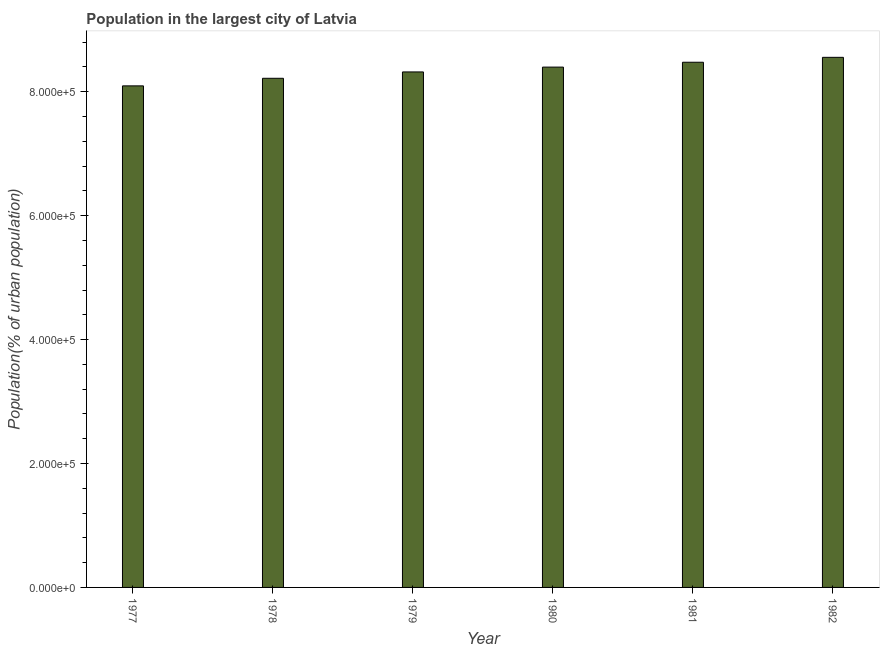Does the graph contain any zero values?
Offer a terse response. No. Does the graph contain grids?
Ensure brevity in your answer.  No. What is the title of the graph?
Provide a short and direct response. Population in the largest city of Latvia. What is the label or title of the X-axis?
Your answer should be compact. Year. What is the label or title of the Y-axis?
Offer a terse response. Population(% of urban population). What is the population in largest city in 1979?
Offer a very short reply. 8.32e+05. Across all years, what is the maximum population in largest city?
Ensure brevity in your answer.  8.56e+05. Across all years, what is the minimum population in largest city?
Your answer should be compact. 8.09e+05. In which year was the population in largest city minimum?
Provide a succinct answer. 1977. What is the sum of the population in largest city?
Keep it short and to the point. 5.01e+06. What is the difference between the population in largest city in 1977 and 1979?
Your answer should be very brief. -2.25e+04. What is the average population in largest city per year?
Keep it short and to the point. 8.34e+05. What is the median population in largest city?
Give a very brief answer. 8.36e+05. Do a majority of the years between 1977 and 1981 (inclusive) have population in largest city greater than 520000 %?
Ensure brevity in your answer.  Yes. Is the population in largest city in 1978 less than that in 1980?
Offer a terse response. Yes. Is the difference between the population in largest city in 1977 and 1978 greater than the difference between any two years?
Provide a succinct answer. No. What is the difference between the highest and the second highest population in largest city?
Your answer should be very brief. 7930. Is the sum of the population in largest city in 1977 and 1980 greater than the maximum population in largest city across all years?
Provide a succinct answer. Yes. What is the difference between the highest and the lowest population in largest city?
Make the answer very short. 4.61e+04. Are all the bars in the graph horizontal?
Offer a very short reply. No. Are the values on the major ticks of Y-axis written in scientific E-notation?
Give a very brief answer. Yes. What is the Population(% of urban population) in 1977?
Your answer should be compact. 8.09e+05. What is the Population(% of urban population) of 1978?
Your answer should be very brief. 8.22e+05. What is the Population(% of urban population) of 1979?
Ensure brevity in your answer.  8.32e+05. What is the Population(% of urban population) of 1980?
Your answer should be very brief. 8.40e+05. What is the Population(% of urban population) in 1981?
Provide a succinct answer. 8.48e+05. What is the Population(% of urban population) in 1982?
Your answer should be very brief. 8.56e+05. What is the difference between the Population(% of urban population) in 1977 and 1978?
Your answer should be very brief. -1.22e+04. What is the difference between the Population(% of urban population) in 1977 and 1979?
Offer a terse response. -2.25e+04. What is the difference between the Population(% of urban population) in 1977 and 1980?
Offer a terse response. -3.03e+04. What is the difference between the Population(% of urban population) in 1977 and 1981?
Ensure brevity in your answer.  -3.81e+04. What is the difference between the Population(% of urban population) in 1977 and 1982?
Provide a short and direct response. -4.61e+04. What is the difference between the Population(% of urban population) in 1978 and 1979?
Make the answer very short. -1.03e+04. What is the difference between the Population(% of urban population) in 1978 and 1980?
Your response must be concise. -1.81e+04. What is the difference between the Population(% of urban population) in 1978 and 1981?
Provide a succinct answer. -2.59e+04. What is the difference between the Population(% of urban population) in 1978 and 1982?
Make the answer very short. -3.38e+04. What is the difference between the Population(% of urban population) in 1979 and 1980?
Offer a very short reply. -7794. What is the difference between the Population(% of urban population) in 1979 and 1981?
Your answer should be compact. -1.56e+04. What is the difference between the Population(% of urban population) in 1979 and 1982?
Your answer should be compact. -2.36e+04. What is the difference between the Population(% of urban population) in 1980 and 1981?
Your answer should be compact. -7846. What is the difference between the Population(% of urban population) in 1980 and 1982?
Your answer should be compact. -1.58e+04. What is the difference between the Population(% of urban population) in 1981 and 1982?
Make the answer very short. -7930. What is the ratio of the Population(% of urban population) in 1977 to that in 1979?
Provide a short and direct response. 0.97. What is the ratio of the Population(% of urban population) in 1977 to that in 1980?
Give a very brief answer. 0.96. What is the ratio of the Population(% of urban population) in 1977 to that in 1981?
Your response must be concise. 0.95. What is the ratio of the Population(% of urban population) in 1977 to that in 1982?
Keep it short and to the point. 0.95. What is the ratio of the Population(% of urban population) in 1978 to that in 1980?
Keep it short and to the point. 0.98. What is the ratio of the Population(% of urban population) in 1978 to that in 1981?
Offer a terse response. 0.97. What is the ratio of the Population(% of urban population) in 1979 to that in 1981?
Your response must be concise. 0.98. What is the ratio of the Population(% of urban population) in 1979 to that in 1982?
Provide a succinct answer. 0.97. What is the ratio of the Population(% of urban population) in 1981 to that in 1982?
Offer a terse response. 0.99. 